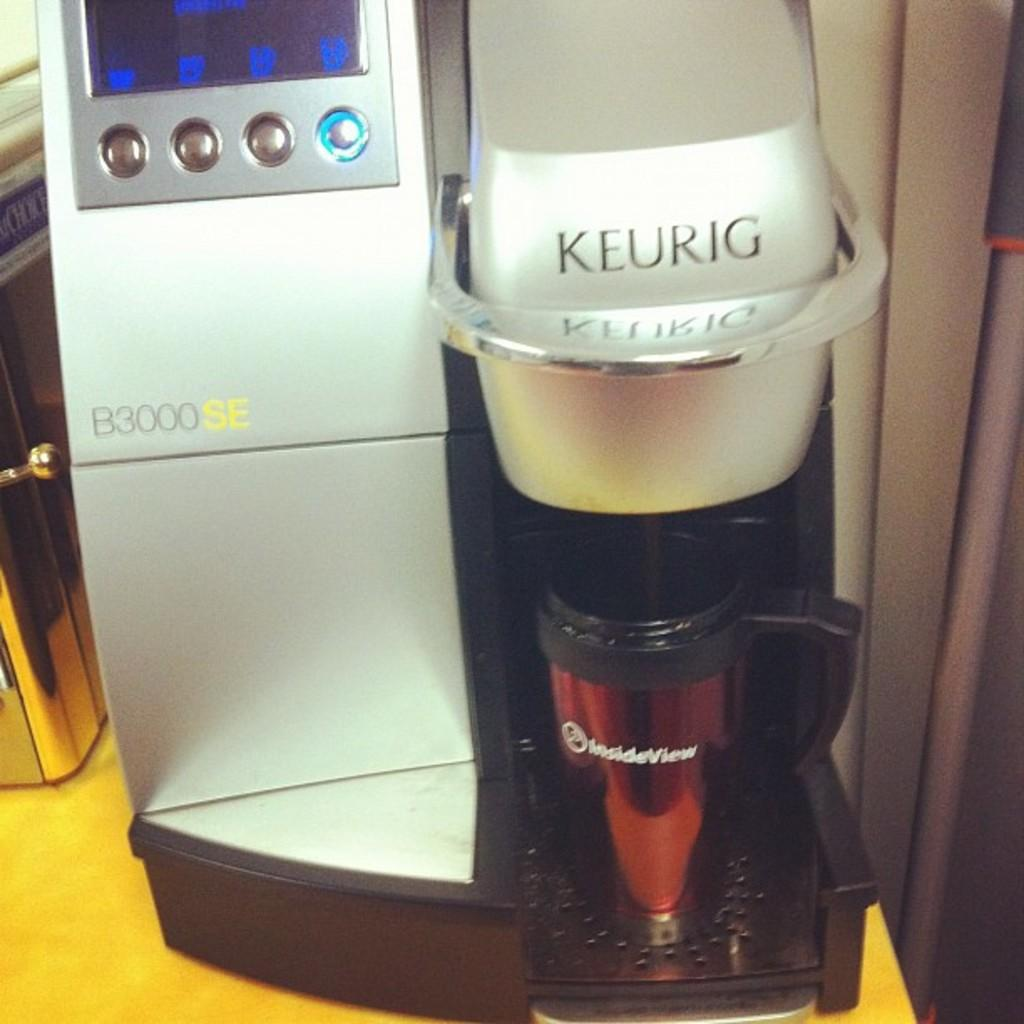<image>
Write a terse but informative summary of the picture. a Keurig B3000SE coffee maker with a mug receiving coffee 